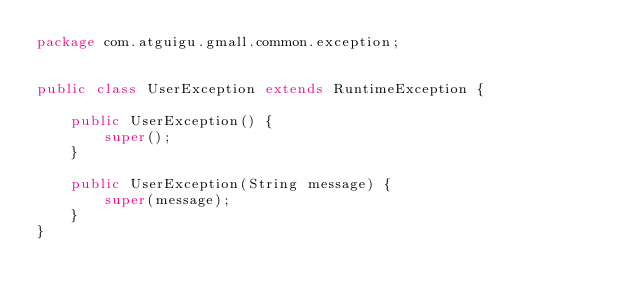<code> <loc_0><loc_0><loc_500><loc_500><_Java_>package com.atguigu.gmall.common.exception;


public class UserException extends RuntimeException {

    public UserException() {
        super();
    }

    public UserException(String message) {
        super(message);
    }
}
</code> 